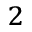<formula> <loc_0><loc_0><loc_500><loc_500>^ { 2 }</formula> 